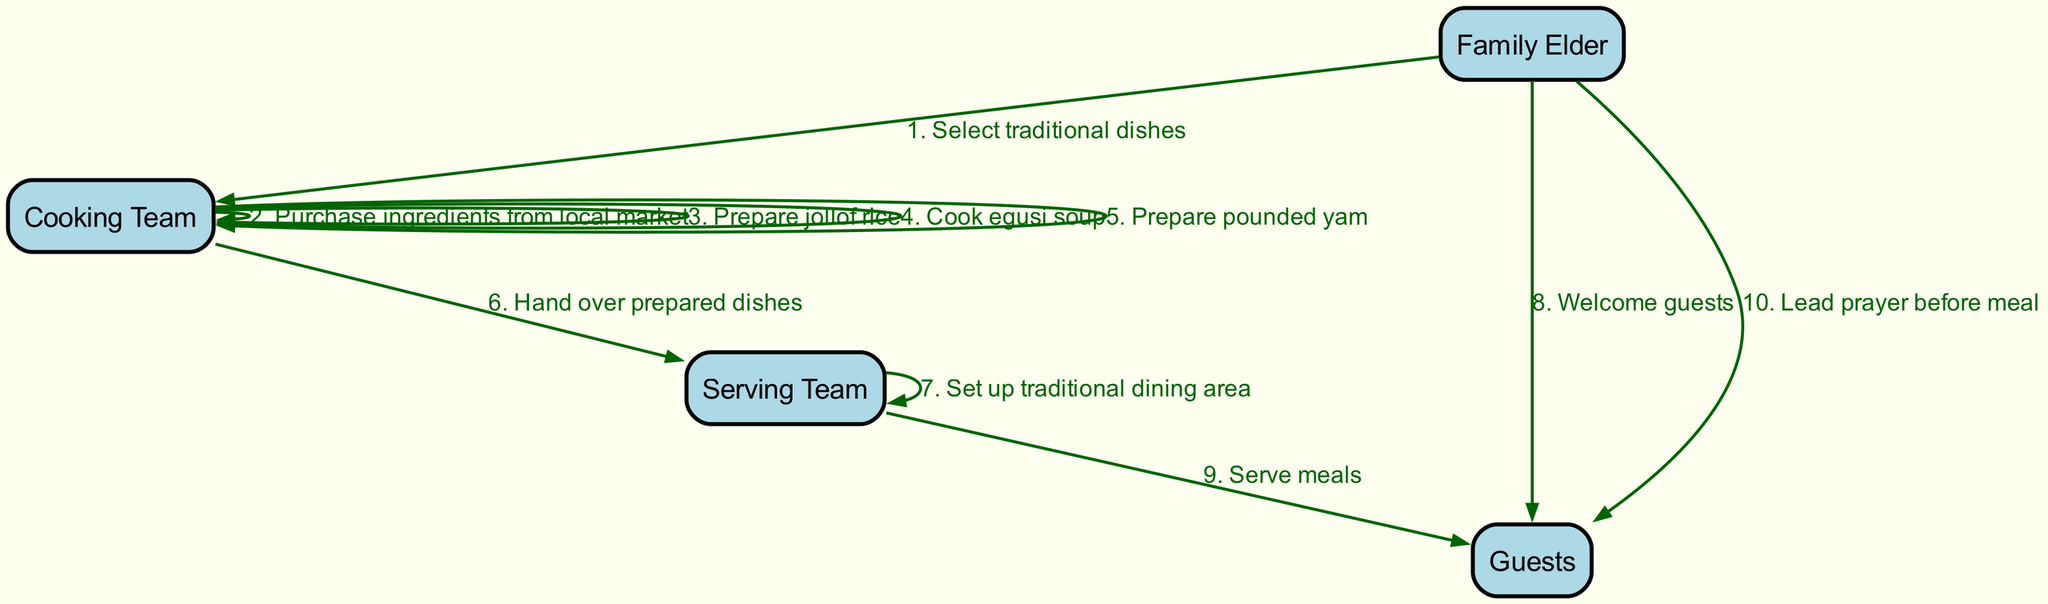What is the first action performed in the sequence? The sequence starts with the Family Elder selecting traditional dishes, which is the first action indicated in the diagram.
Answer: Select traditional dishes Who is responsible for purchasing ingredients? The Cooking Team is responsible for purchasing ingredients, as shown in the sequence where they take this action for meal preparation.
Answer: Cooking Team What does the Serving Team do after receiving the prepared dishes? After receiving the prepared dishes from the Cooking Team, the Serving Team sets up the traditional dining area as the next action in the sequence.
Answer: Set up traditional dining area How many dishes are prepared by the Cooking Team? The Cooking Team prepares three dishes in total: jollof rice, egusi soup, and pounded yam, as noted in the sequence of actions.
Answer: Three What is the last action performed by the Family Elder? The last action performed by the Family Elder is to lead a prayer before the meal, which occurs just before the guests start eating.
Answer: Lead prayer before meal Which actors are involved in serving the meals? The Serving Team is specifically mentioned as the group that serves the meals to the guests, as indicated in the sequence diagram.
Answer: Serving Team What is the relationship between the Cooking Team and the Serving Team? The Cooking Team hands over the prepared dishes to the Serving Team, establishing a flow of work between them in the meal preparation process.
Answer: Hands over prepared dishes What action follows after welcoming guests? After the Family Elder welcomes the guests, the Serving Team serves the meals to them, which is the next action in the flow.
Answer: Serve meals How many total actions are depicted in the diagram? The diagram contains a total of ten actions, as indicated by the number of sequential steps represented between the various actors.
Answer: Ten 